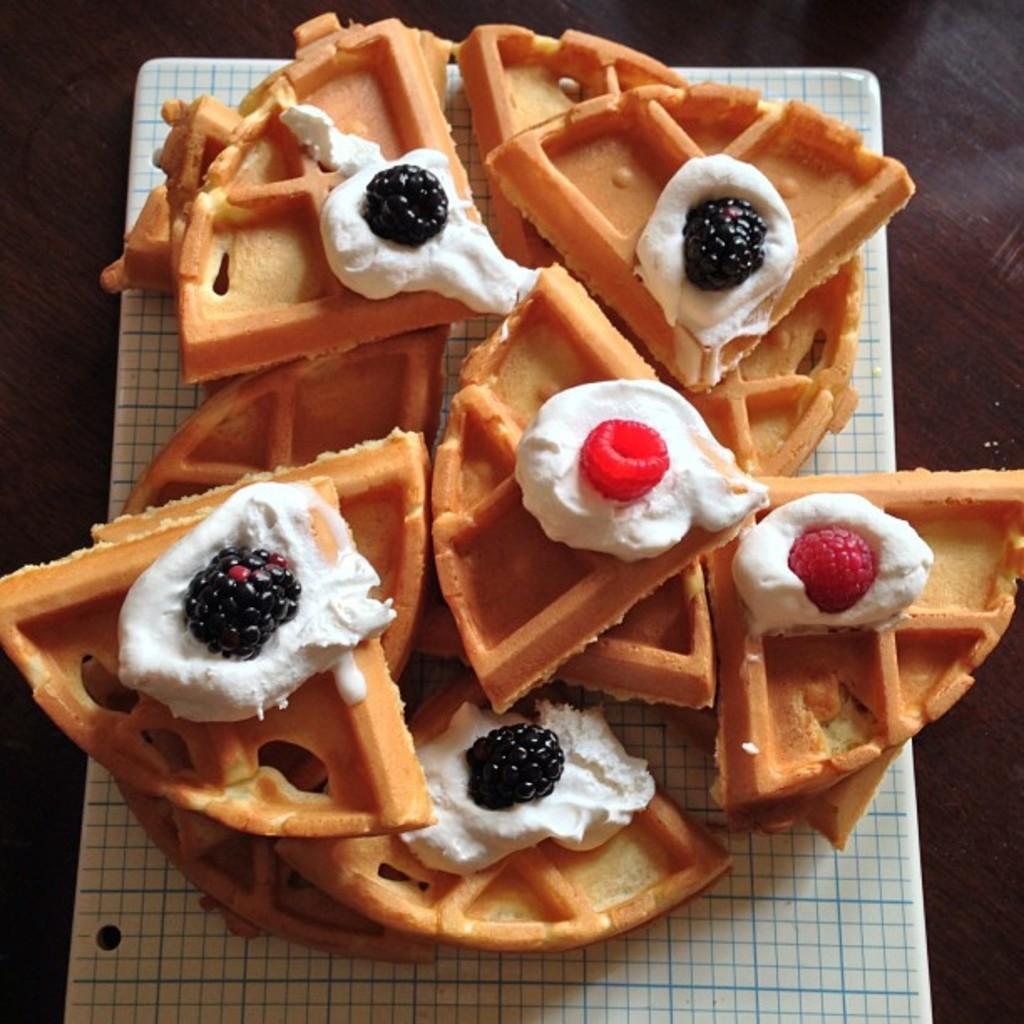Can you describe this image briefly? There are waffles on which there is a cream and berry topping. 